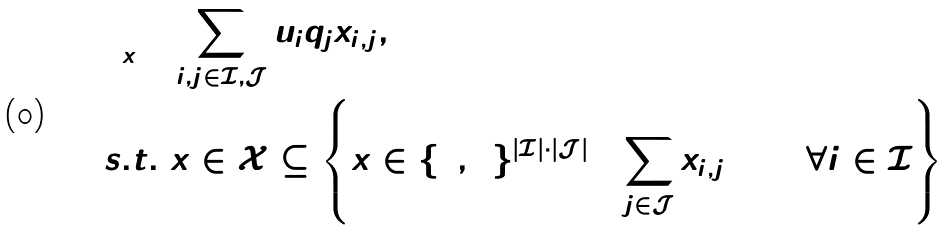<formula> <loc_0><loc_0><loc_500><loc_500>\min _ { x } & \ \sum _ { i , j \in \mathcal { I } , \mathcal { J } } u _ { i } q _ { j } x _ { i , j } , \\ s . t . & \ x \in \mathcal { X } \subseteq \left \{ x \in \{ 0 , 1 \} ^ { | \mathcal { I } | \cdot | \mathcal { J } | } \colon \sum _ { j \in \mathcal { J } } x _ { i , j } = 1 \ \forall i \in \mathcal { I } \right \}</formula> 